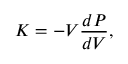Convert formula to latex. <formula><loc_0><loc_0><loc_500><loc_500>K = - V \frac { d P } { d V } ,</formula> 